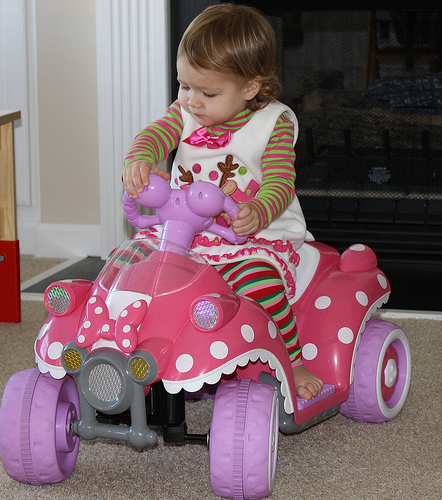<image>
Is the little girl on the toy car? Yes. Looking at the image, I can see the little girl is positioned on top of the toy car, with the toy car providing support. Is there a girl on the floor? No. The girl is not positioned on the floor. They may be near each other, but the girl is not supported by or resting on top of the floor. Where is the baby in relation to the wall? Is it next to the wall? No. The baby is not positioned next to the wall. They are located in different areas of the scene. 